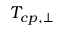<formula> <loc_0><loc_0><loc_500><loc_500>T _ { c p , \perp }</formula> 